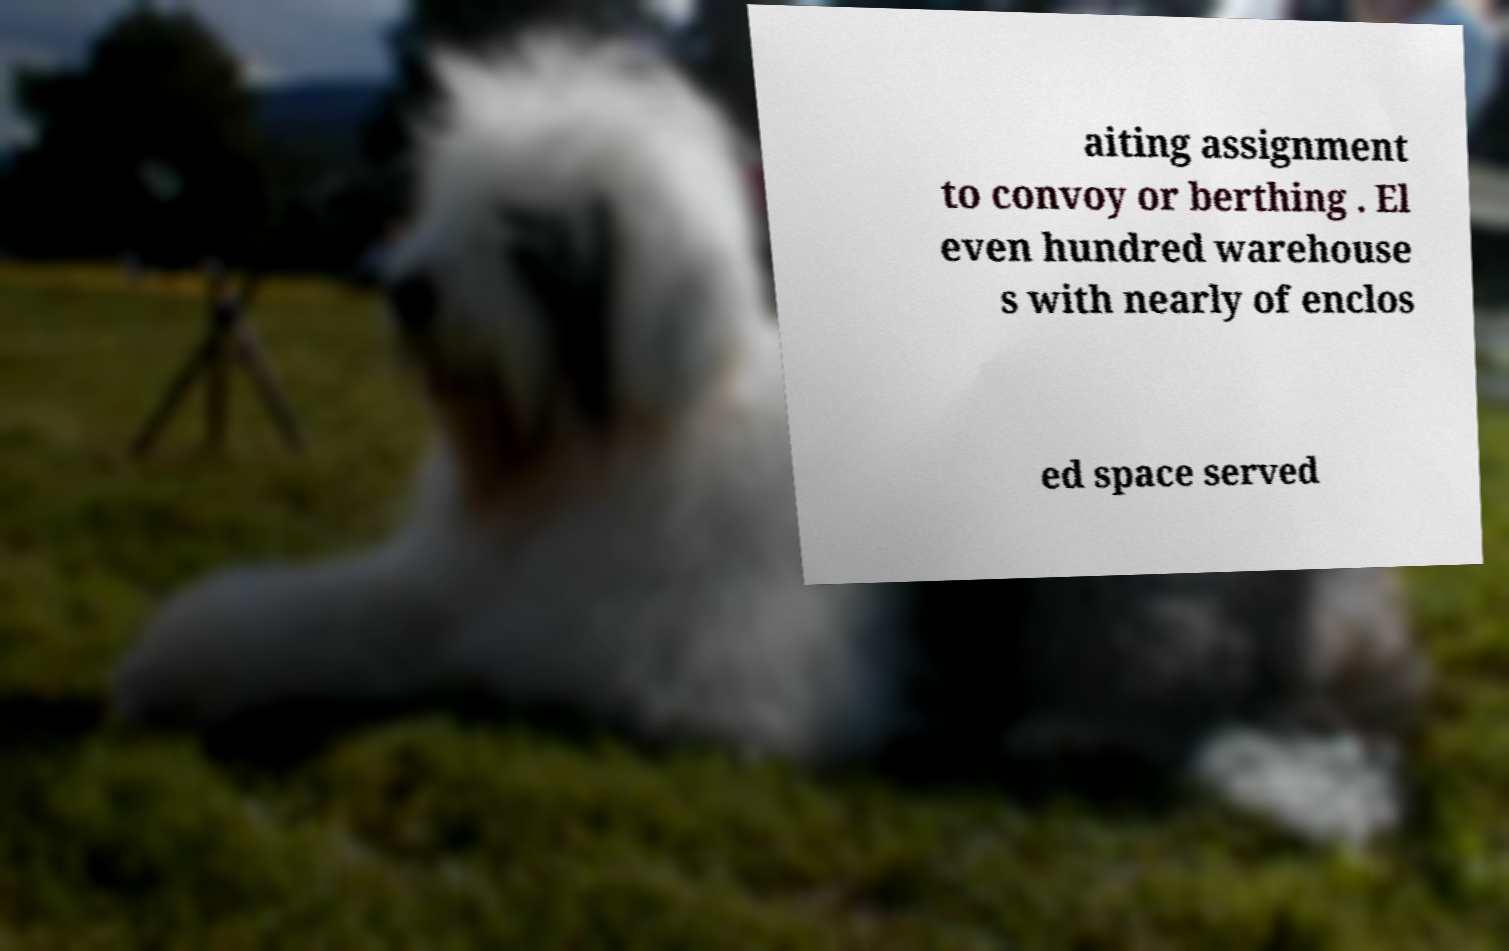There's text embedded in this image that I need extracted. Can you transcribe it verbatim? aiting assignment to convoy or berthing . El even hundred warehouse s with nearly of enclos ed space served 